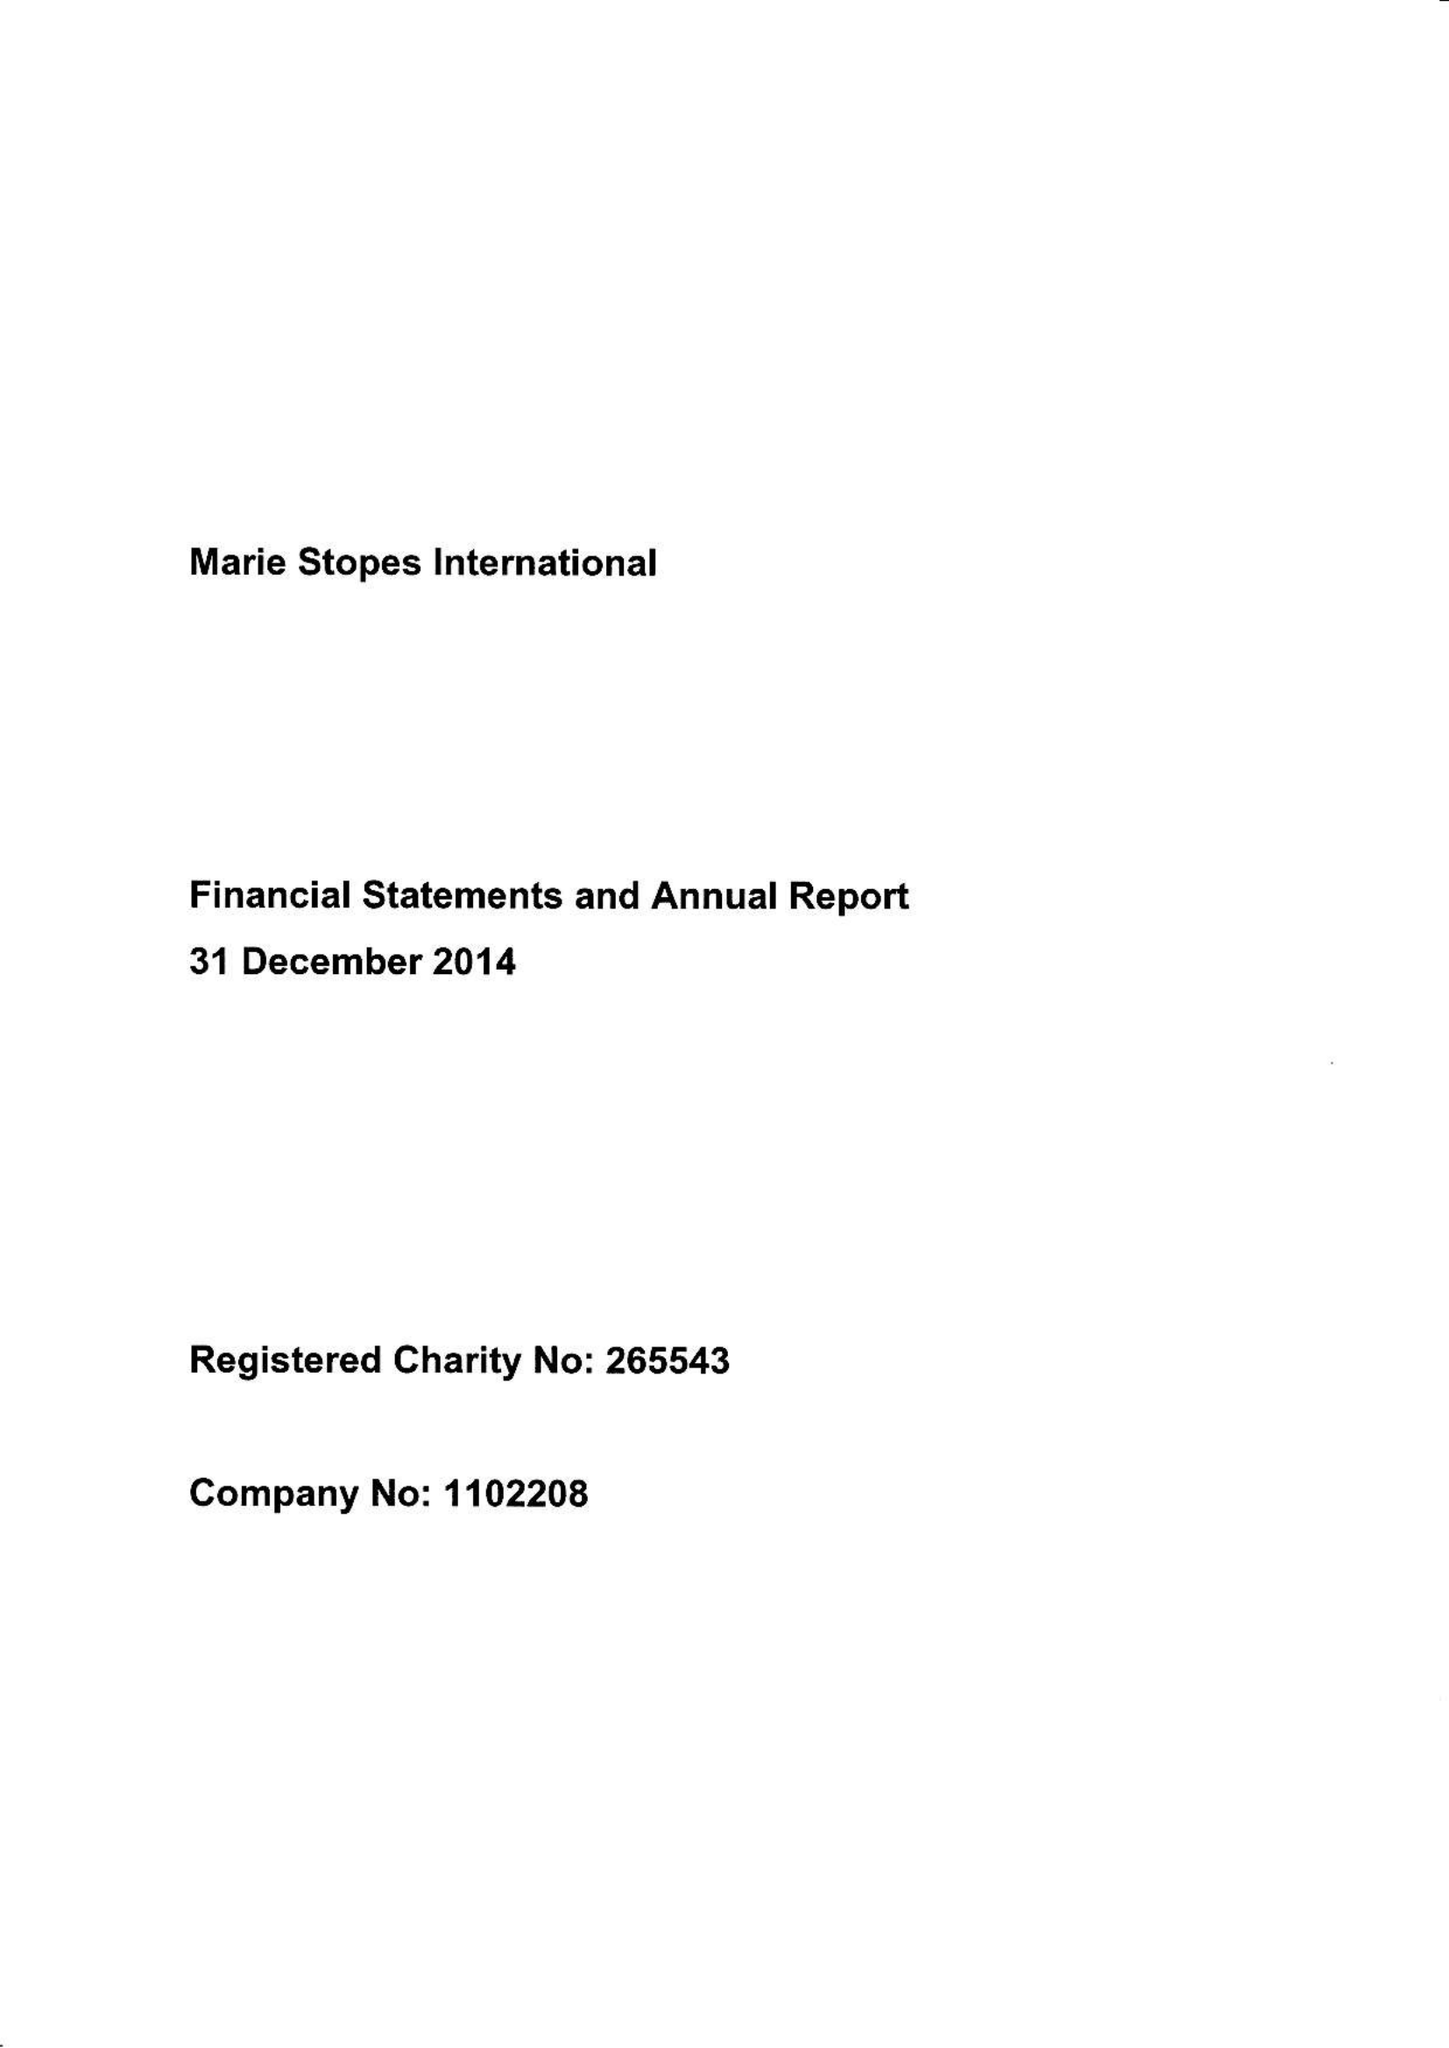What is the value for the charity_name?
Answer the question using a single word or phrase. Marie Stopes International 